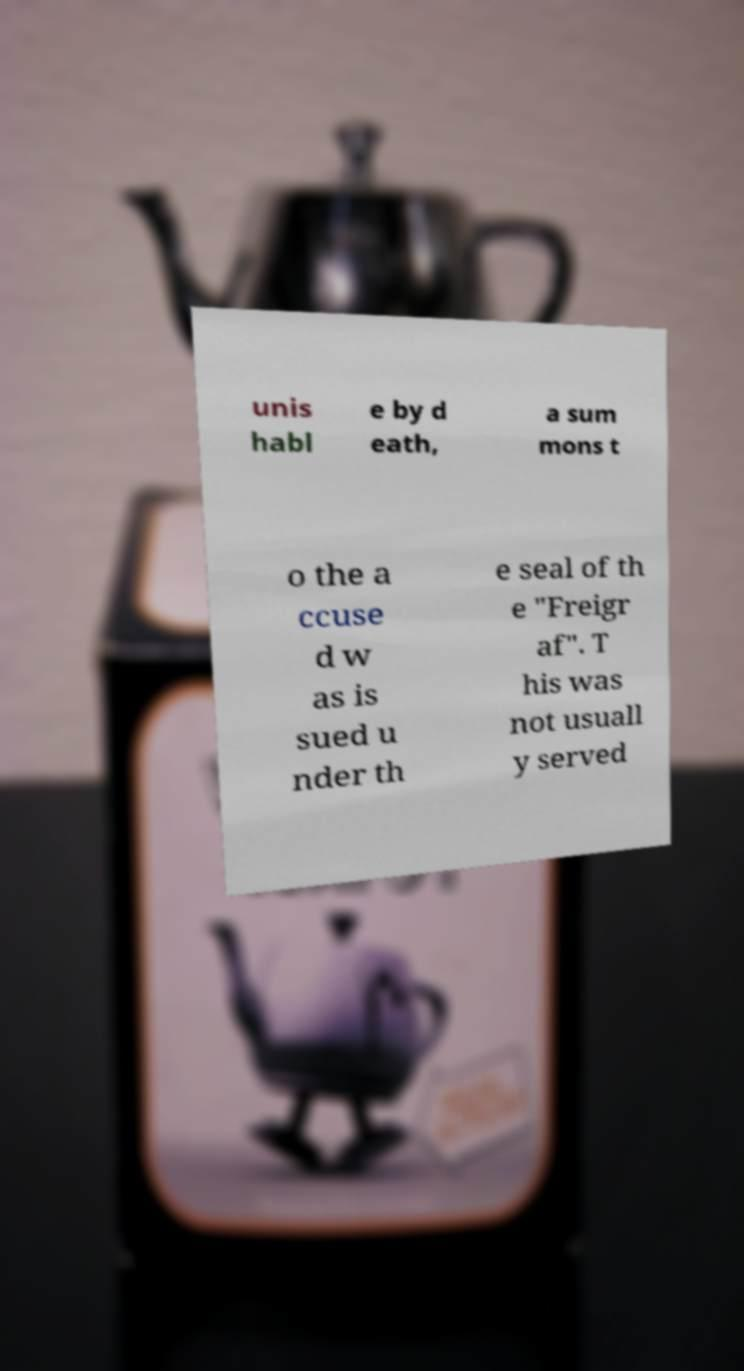What messages or text are displayed in this image? I need them in a readable, typed format. unis habl e by d eath, a sum mons t o the a ccuse d w as is sued u nder th e seal of th e "Freigr af". T his was not usuall y served 